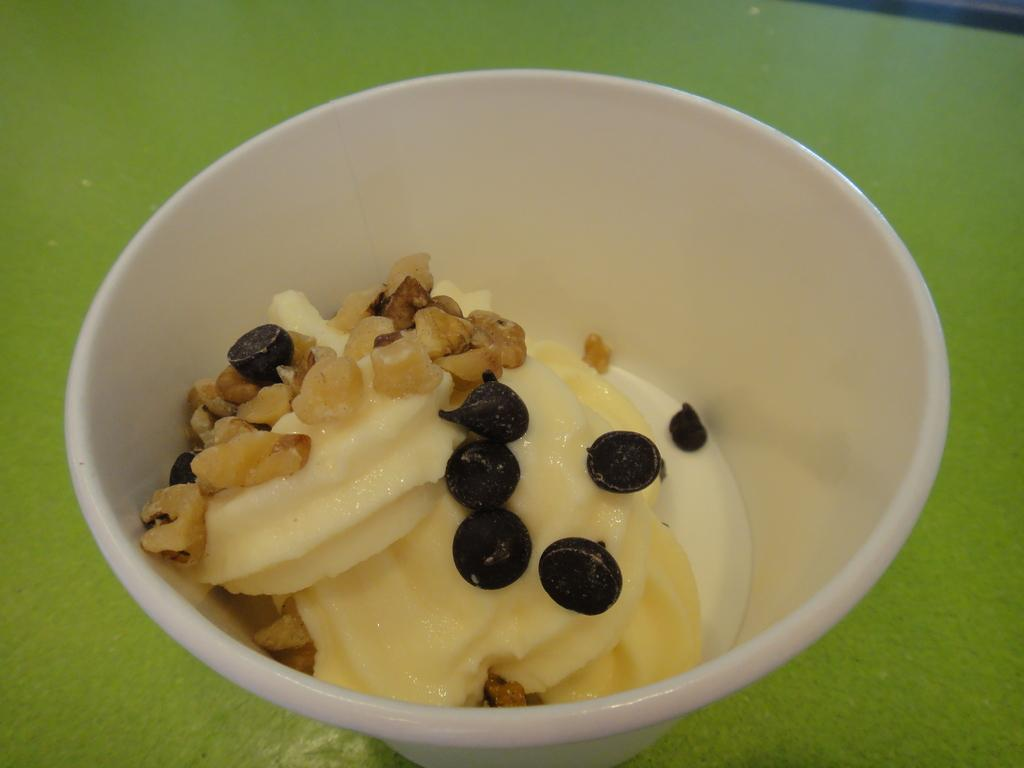What color is the bowl in the image? The bowl in the image is white. What is inside the bowl? The bowl contains ice cream. What are some of the ingredients in the ice cream? The ice cream has chocolate chips and some dry fruits. What is the bowl placed on? The bowl is placed on a green color object. What type of circle can be seen in the ice cream? There is no circle present in the ice cream; it is a mixture of ice cream, chocolate chips, and dry fruits. 